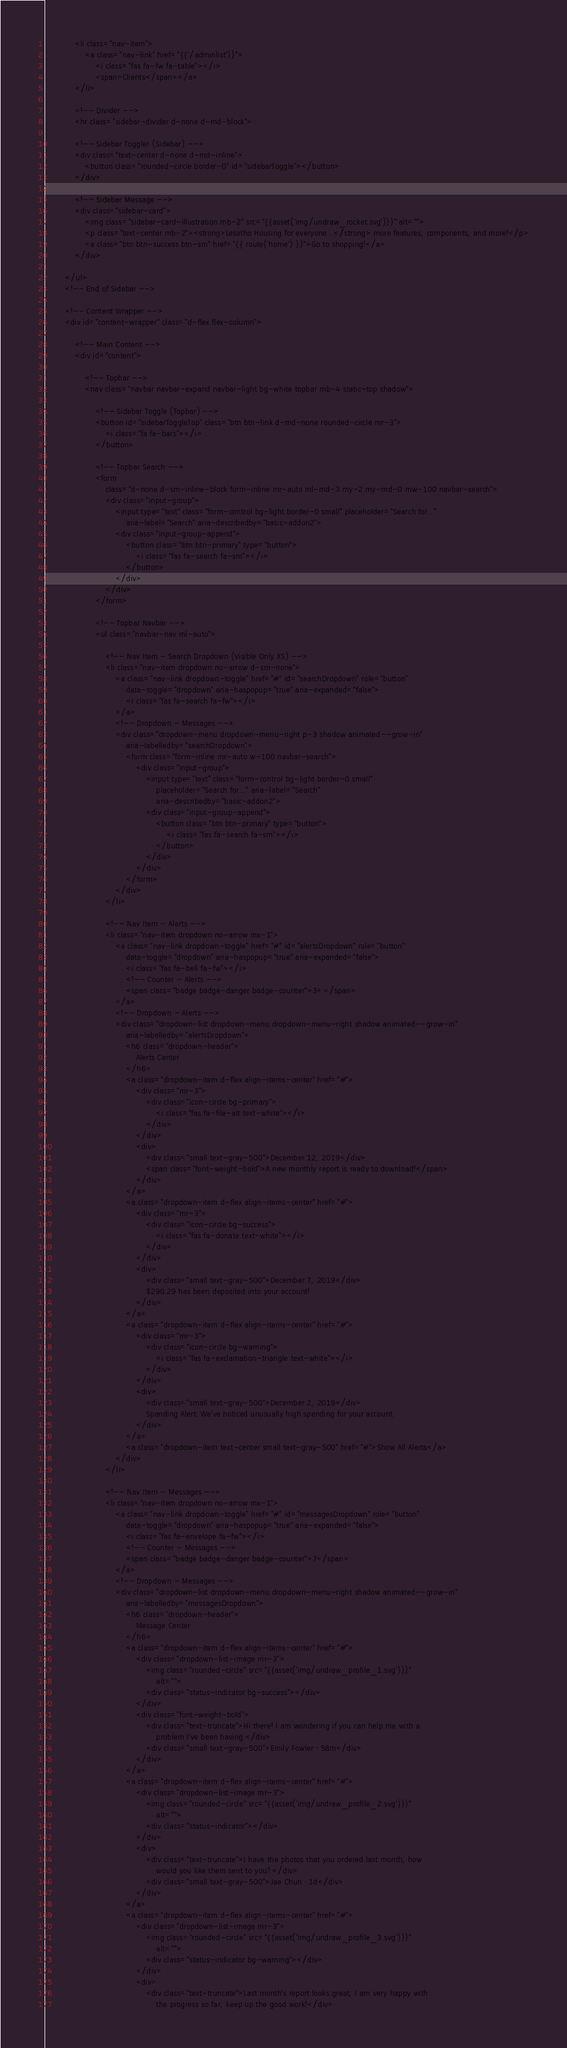<code> <loc_0><loc_0><loc_500><loc_500><_PHP_>            <li class="nav-item">
                <a class="nav-link" href="{{'/adminlist'}}">
                    <i class="fas fa-fw fa-table"></i>
                    <span>Clients</span></a>
            </li>

            <!-- Divider -->
            <hr class="sidebar-divider d-none d-md-block">

            <!-- Sidebar Toggler (Sidebar) -->
            <div class="text-center d-none d-md-inline">
                <button class="rounded-circle border-0" id="sidebarToggle"></button>
            </div>

            <!-- Sidebar Message -->
            <div class="sidebar-card">
                <img class="sidebar-card-illustration mb-2" src="{{asset('img/undraw_rocket.svg')}}" alt="">
                <p class="text-center mb-2"><strong>Lesotho Housing for everyone...</strong> more features, components, and more!</p>
                <a class="btn btn-success btn-sm" href="{{ route('home') }}">Go to shopping!</a>
            </div>

        </ul>
        <!-- End of Sidebar -->

        <!-- Content Wrapper -->
        <div id="content-wrapper" class="d-flex flex-column">

            <!-- Main Content -->
            <div id="content">

                <!-- Topbar -->
                <nav class="navbar navbar-expand navbar-light bg-white topbar mb-4 static-top shadow">

                    <!-- Sidebar Toggle (Topbar) -->
                    <button id="sidebarToggleTop" class="btn btn-link d-md-none rounded-circle mr-3">
                        <i class="fa fa-bars"></i>
                    </button>

                    <!-- Topbar Search -->
                    <form
                        class="d-none d-sm-inline-block form-inline mr-auto ml-md-3 my-2 my-md-0 mw-100 navbar-search">
                        <div class="input-group">
                            <input type="text" class="form-control bg-light border-0 small" placeholder="Search for..."
                                aria-label="Search" aria-describedby="basic-addon2">
                            <div class="input-group-append">
                                <button class="btn btn-primary" type="button">
                                    <i class="fas fa-search fa-sm"></i>
                                </button>
                            </div>
                        </div>
                    </form>

                    <!-- Topbar Navbar -->
                    <ul class="navbar-nav ml-auto">

                        <!-- Nav Item - Search Dropdown (Visible Only XS) -->
                        <li class="nav-item dropdown no-arrow d-sm-none">
                            <a class="nav-link dropdown-toggle" href="#" id="searchDropdown" role="button"
                                data-toggle="dropdown" aria-haspopup="true" aria-expanded="false">
                                <i class="fas fa-search fa-fw"></i>
                            </a>
                            <!-- Dropdown - Messages -->
                            <div class="dropdown-menu dropdown-menu-right p-3 shadow animated--grow-in"
                                aria-labelledby="searchDropdown">
                                <form class="form-inline mr-auto w-100 navbar-search">
                                    <div class="input-group">
                                        <input type="text" class="form-control bg-light border-0 small"
                                            placeholder="Search for..." aria-label="Search"
                                            aria-describedby="basic-addon2">
                                        <div class="input-group-append">
                                            <button class="btn btn-primary" type="button">
                                                <i class="fas fa-search fa-sm"></i>
                                            </button>
                                        </div>
                                    </div>
                                </form>
                            </div>
                        </li>

                        <!-- Nav Item - Alerts -->
                        <li class="nav-item dropdown no-arrow mx-1">
                            <a class="nav-link dropdown-toggle" href="#" id="alertsDropdown" role="button"
                                data-toggle="dropdown" aria-haspopup="true" aria-expanded="false">
                                <i class="fas fa-bell fa-fw"></i>
                                <!-- Counter - Alerts -->
                                <span class="badge badge-danger badge-counter">3+</span>
                            </a>
                            <!-- Dropdown - Alerts -->
                            <div class="dropdown-list dropdown-menu dropdown-menu-right shadow animated--grow-in"
                                aria-labelledby="alertsDropdown">
                                <h6 class="dropdown-header">
                                    Alerts Center
                                </h6>
                                <a class="dropdown-item d-flex align-items-center" href="#">
                                    <div class="mr-3">
                                        <div class="icon-circle bg-primary">
                                            <i class="fas fa-file-alt text-white"></i>
                                        </div>
                                    </div>
                                    <div>
                                        <div class="small text-gray-500">December 12, 2019</div>
                                        <span class="font-weight-bold">A new monthly report is ready to download!</span>
                                    </div>
                                </a>
                                <a class="dropdown-item d-flex align-items-center" href="#">
                                    <div class="mr-3">
                                        <div class="icon-circle bg-success">
                                            <i class="fas fa-donate text-white"></i>
                                        </div>
                                    </div>
                                    <div>
                                        <div class="small text-gray-500">December 7, 2019</div>
                                        $290.29 has been deposited into your account!
                                    </div>
                                </a>
                                <a class="dropdown-item d-flex align-items-center" href="#">
                                    <div class="mr-3">
                                        <div class="icon-circle bg-warning">
                                            <i class="fas fa-exclamation-triangle text-white"></i>
                                        </div>
                                    </div>
                                    <div>
                                        <div class="small text-gray-500">December 2, 2019</div>
                                        Spending Alert: We've noticed unusually high spending for your account.
                                    </div>
                                </a>
                                <a class="dropdown-item text-center small text-gray-500" href="#">Show All Alerts</a>
                            </div>
                        </li>

                        <!-- Nav Item - Messages -->
                        <li class="nav-item dropdown no-arrow mx-1">
                            <a class="nav-link dropdown-toggle" href="#" id="messagesDropdown" role="button"
                                data-toggle="dropdown" aria-haspopup="true" aria-expanded="false">
                                <i class="fas fa-envelope fa-fw"></i>
                                <!-- Counter - Messages -->
                                <span class="badge badge-danger badge-counter">7</span>
                            </a>
                            <!-- Dropdown - Messages -->
                            <div class="dropdown-list dropdown-menu dropdown-menu-right shadow animated--grow-in"
                                aria-labelledby="messagesDropdown">
                                <h6 class="dropdown-header">
                                    Message Center
                                </h6>
                                <a class="dropdown-item d-flex align-items-center" href="#">
                                    <div class="dropdown-list-image mr-3">
                                        <img class="rounded-circle" src="{{asset('img/undraw_profile_1.svg')}}"
                                            alt="">
                                        <div class="status-indicator bg-success"></div>
                                    </div>
                                    <div class="font-weight-bold">
                                        <div class="text-truncate">Hi there! I am wondering if you can help me with a
                                            problem I've been having.</div>
                                        <div class="small text-gray-500">Emily Fowler · 58m</div>
                                    </div>
                                </a>
                                <a class="dropdown-item d-flex align-items-center" href="#">
                                    <div class="dropdown-list-image mr-3">
                                        <img class="rounded-circle" src="{{asset('img/undraw_profile_2.svg')}}"
                                            alt="">
                                        <div class="status-indicator"></div>
                                    </div>
                                    <div>
                                        <div class="text-truncate">I have the photos that you ordered last month, how
                                            would you like them sent to you?</div>
                                        <div class="small text-gray-500">Jae Chun · 1d</div>
                                    </div>
                                </a>
                                <a class="dropdown-item d-flex align-items-center" href="#">
                                    <div class="dropdown-list-image mr-3">
                                        <img class="rounded-circle" src="{{asset('img/undraw_profile_3.svg')}}"
                                            alt="">
                                        <div class="status-indicator bg-warning"></div>
                                    </div>
                                    <div>
                                        <div class="text-truncate">Last month's report looks great, I am very happy with
                                            the progress so far, keep up the good work!</div></code> 